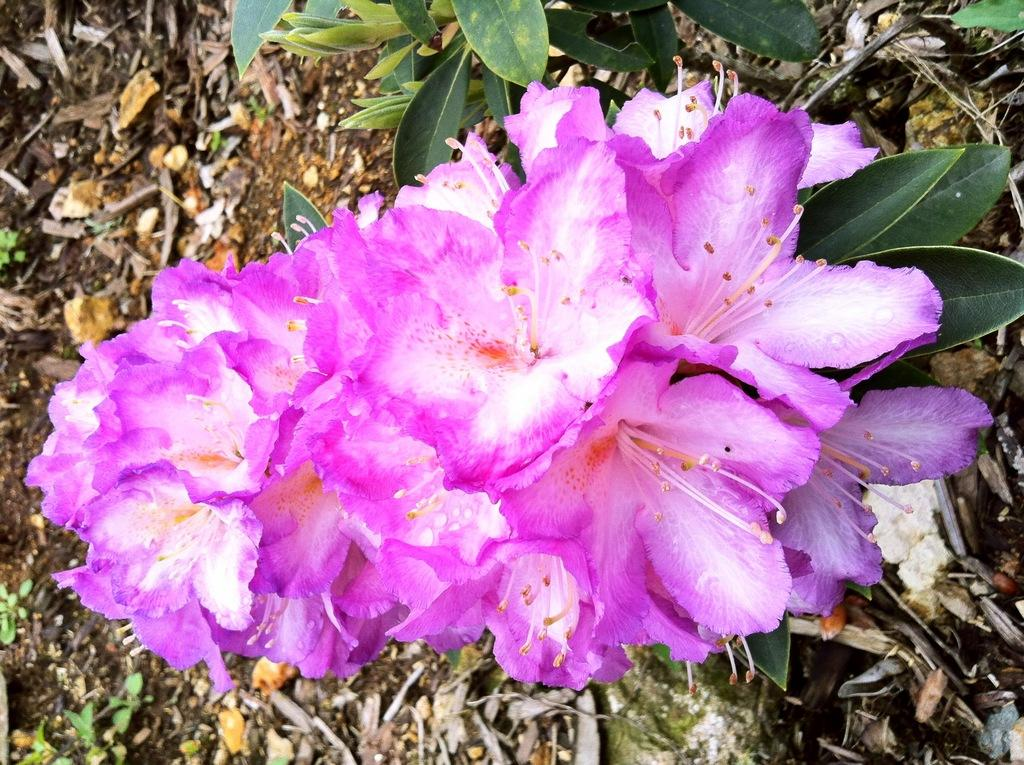What type of plants can be seen in the image? There are flowers and green leaves in the image. What is the color of the leaves in the image? The leaves in the image are green. What else can be seen on the ground in the image? There are dried leaves on the ground in the image. How many bikes are parked next to the flowers in the image? There are no bikes present in the image; it only features flowers, green leaves, and dried leaves on the ground. 